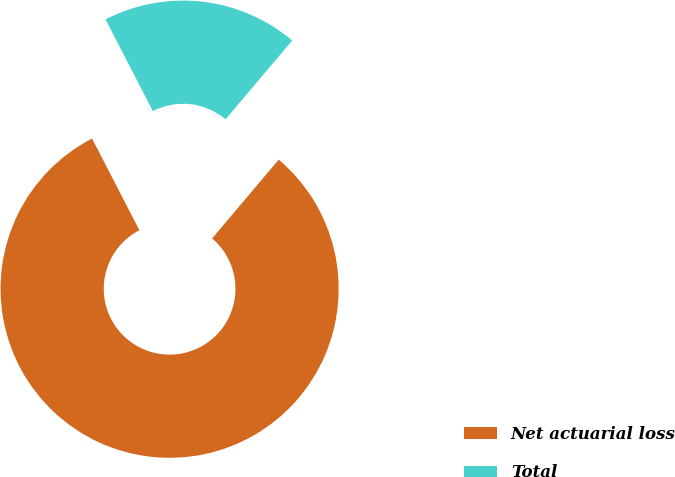Convert chart to OTSL. <chart><loc_0><loc_0><loc_500><loc_500><pie_chart><fcel>Net actuarial loss<fcel>Total<nl><fcel>81.25%<fcel>18.75%<nl></chart> 